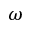Convert formula to latex. <formula><loc_0><loc_0><loc_500><loc_500>\omega</formula> 